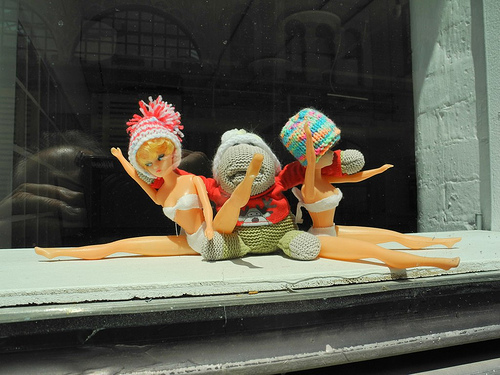<image>
Can you confirm if the glass is in front of the figurines? No. The glass is not in front of the figurines. The spatial positioning shows a different relationship between these objects. 